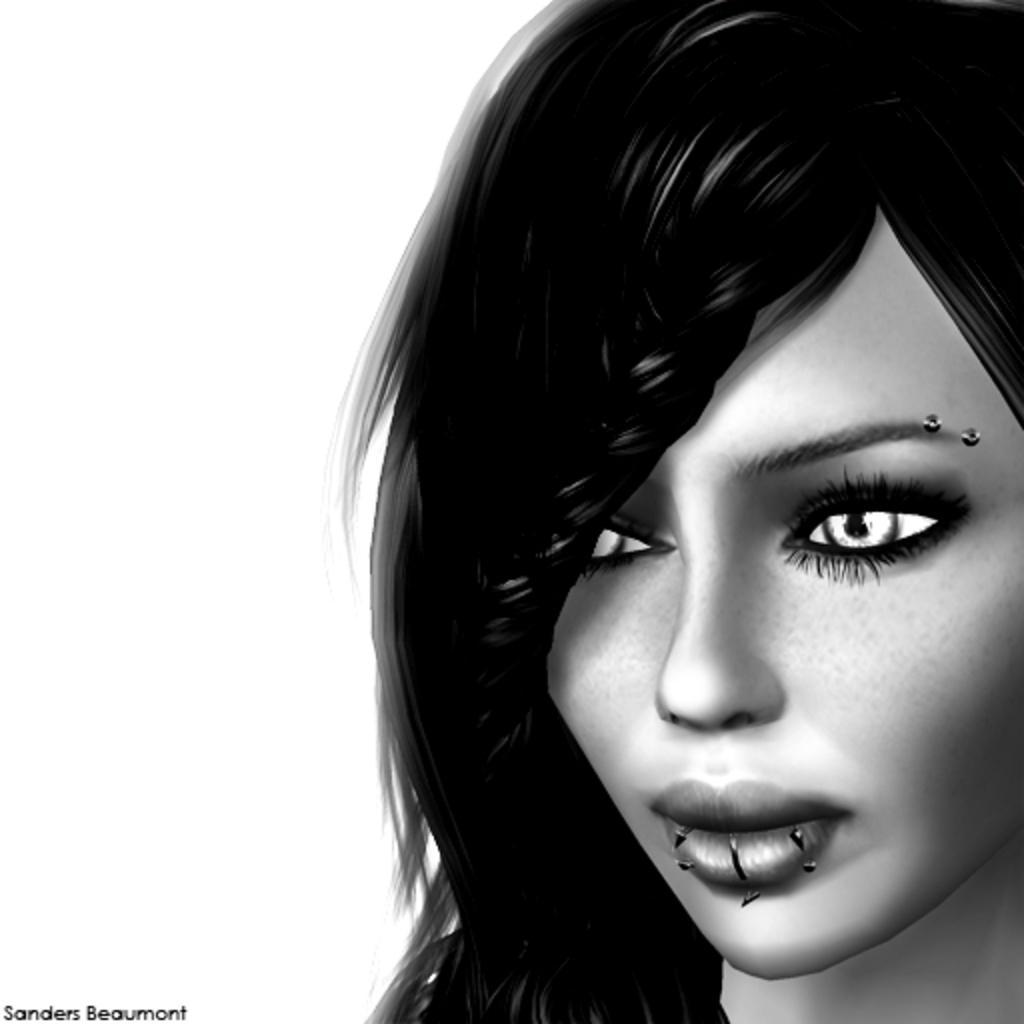How would you summarize this image in a sentence or two? In this image I can see the depiction picture of a woman and on the bottom left side of the image I can see a watermark. I can also see this image is black and white in colour. 